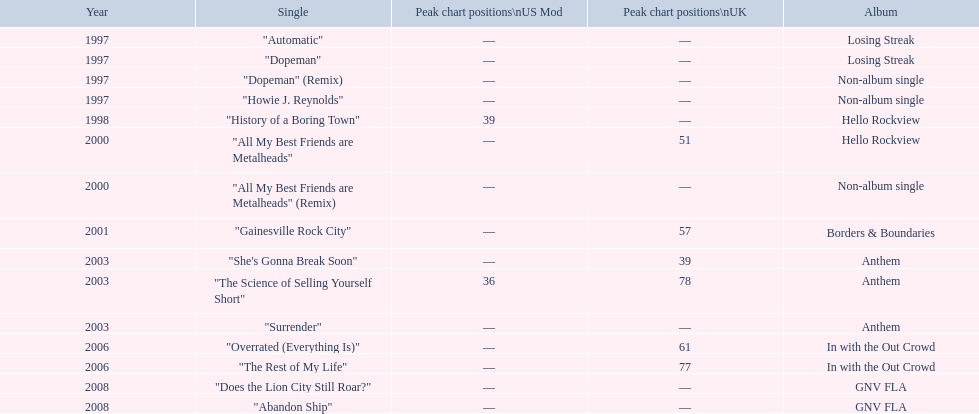Besides "dopeman," can you identify another single from the losing streak album? "Automatic". 